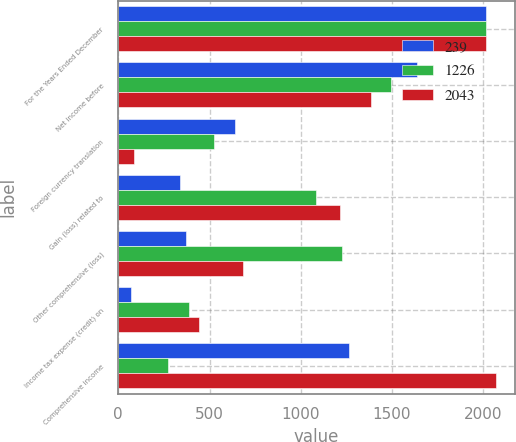Convert chart to OTSL. <chart><loc_0><loc_0><loc_500><loc_500><stacked_bar_chart><ecel><fcel>For the Years Ended December<fcel>Net income before<fcel>Foreign currency translation<fcel>Gain (loss) related to<fcel>Other comprehensive (loss)<fcel>Income tax expense (credit) on<fcel>Comprehensive income<nl><fcel>239<fcel>2015<fcel>1636<fcel>639<fcel>337<fcel>373<fcel>72<fcel>1263<nl><fcel>1226<fcel>2014<fcel>1497<fcel>527<fcel>1085<fcel>1226<fcel>386<fcel>271<nl><fcel>2043<fcel>2013<fcel>1385<fcel>86<fcel>1213<fcel>686<fcel>442<fcel>2071<nl></chart> 